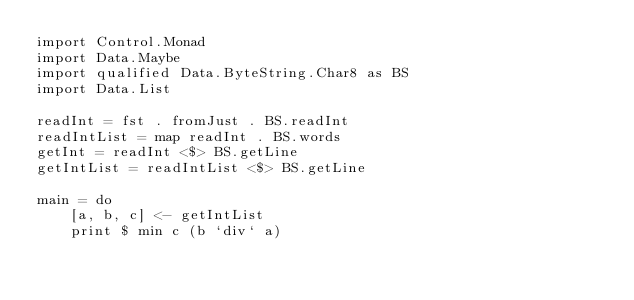<code> <loc_0><loc_0><loc_500><loc_500><_Haskell_>import Control.Monad
import Data.Maybe
import qualified Data.ByteString.Char8 as BS
import Data.List

readInt = fst . fromJust . BS.readInt
readIntList = map readInt . BS.words
getInt = readInt <$> BS.getLine
getIntList = readIntList <$> BS.getLine

main = do
    [a, b, c] <- getIntList
    print $ min c (b `div` a)</code> 